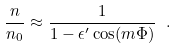<formula> <loc_0><loc_0><loc_500><loc_500>\frac { n } { n _ { 0 } } \approx \frac { 1 } { 1 - \epsilon ^ { \prime } \cos ( m \Phi ) } \ .</formula> 